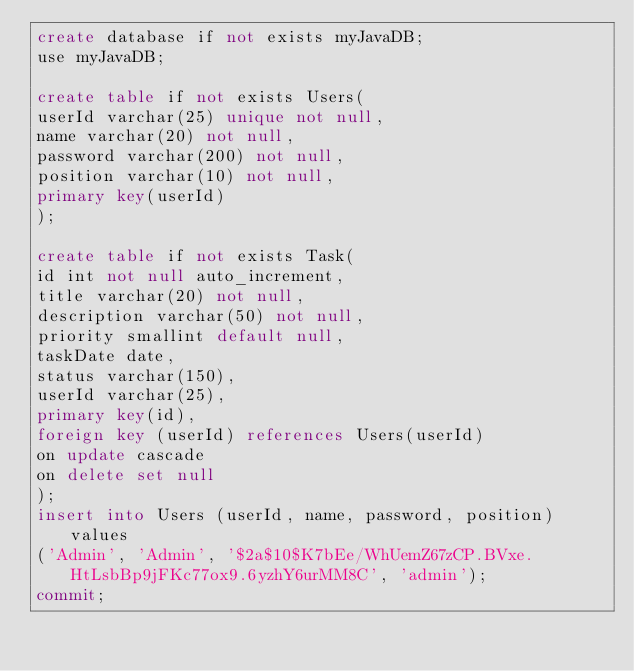Convert code to text. <code><loc_0><loc_0><loc_500><loc_500><_SQL_>create database if not exists myJavaDB;
use myJavaDB;

create table if not exists Users(
userId varchar(25) unique not null,
name varchar(20) not null,
password varchar(200) not null,
position varchar(10) not null,
primary key(userId)
);

create table if not exists Task(
id int not null auto_increment,
title varchar(20) not null,
description varchar(50) not null,
priority smallint default null,
taskDate date,
status varchar(150),
userId varchar(25),
primary key(id),
foreign key (userId) references Users(userId)
on update cascade
on delete set null
);
insert into Users (userId, name, password, position) values
('Admin', 'Admin', '$2a$10$K7bEe/WhUemZ67zCP.BVxe.HtLsbBp9jFKc77ox9.6yzhY6urMM8C', 'admin');
commit;
</code> 